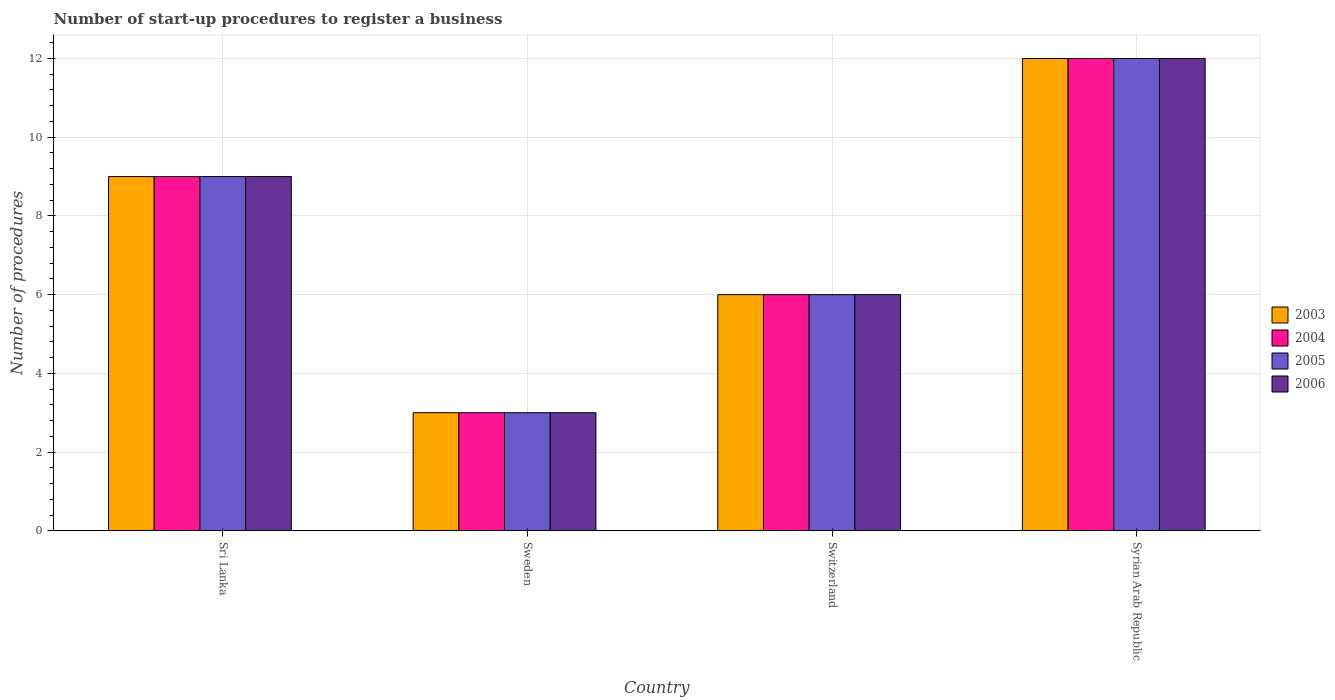How many groups of bars are there?
Provide a succinct answer. 4. Are the number of bars on each tick of the X-axis equal?
Ensure brevity in your answer.  Yes. How many bars are there on the 1st tick from the left?
Provide a succinct answer. 4. How many bars are there on the 1st tick from the right?
Give a very brief answer. 4. What is the label of the 3rd group of bars from the left?
Offer a very short reply. Switzerland. In which country was the number of procedures required to register a business in 2003 maximum?
Your answer should be compact. Syrian Arab Republic. What is the average number of procedures required to register a business in 2003 per country?
Your response must be concise. 7.5. What is the difference between the number of procedures required to register a business of/in 2005 and number of procedures required to register a business of/in 2003 in Syrian Arab Republic?
Offer a terse response. 0. In how many countries, is the number of procedures required to register a business in 2006 greater than 11.2?
Provide a short and direct response. 1. Is the number of procedures required to register a business in 2003 in Sri Lanka less than that in Sweden?
Provide a succinct answer. No. What is the difference between the highest and the lowest number of procedures required to register a business in 2006?
Your answer should be compact. 9. What does the 2nd bar from the left in Syrian Arab Republic represents?
Keep it short and to the point. 2004. What does the 4th bar from the right in Sri Lanka represents?
Your answer should be very brief. 2003. Is it the case that in every country, the sum of the number of procedures required to register a business in 2006 and number of procedures required to register a business in 2004 is greater than the number of procedures required to register a business in 2005?
Offer a terse response. Yes. Are all the bars in the graph horizontal?
Give a very brief answer. No. How many countries are there in the graph?
Provide a succinct answer. 4. What is the difference between two consecutive major ticks on the Y-axis?
Offer a very short reply. 2. Are the values on the major ticks of Y-axis written in scientific E-notation?
Ensure brevity in your answer.  No. Does the graph contain any zero values?
Your answer should be very brief. No. Where does the legend appear in the graph?
Your response must be concise. Center right. How many legend labels are there?
Ensure brevity in your answer.  4. What is the title of the graph?
Make the answer very short. Number of start-up procedures to register a business. What is the label or title of the X-axis?
Ensure brevity in your answer.  Country. What is the label or title of the Y-axis?
Ensure brevity in your answer.  Number of procedures. What is the Number of procedures of 2003 in Sri Lanka?
Provide a succinct answer. 9. What is the Number of procedures of 2003 in Sweden?
Your answer should be very brief. 3. What is the Number of procedures of 2004 in Sweden?
Offer a very short reply. 3. What is the Number of procedures in 2006 in Sweden?
Offer a very short reply. 3. What is the Number of procedures of 2005 in Switzerland?
Provide a short and direct response. 6. What is the Number of procedures in 2006 in Switzerland?
Offer a terse response. 6. What is the Number of procedures of 2006 in Syrian Arab Republic?
Provide a short and direct response. 12. Across all countries, what is the maximum Number of procedures of 2003?
Keep it short and to the point. 12. Across all countries, what is the maximum Number of procedures in 2005?
Keep it short and to the point. 12. Across all countries, what is the minimum Number of procedures in 2005?
Offer a very short reply. 3. Across all countries, what is the minimum Number of procedures of 2006?
Your answer should be very brief. 3. What is the total Number of procedures of 2006 in the graph?
Provide a succinct answer. 30. What is the difference between the Number of procedures of 2003 in Sri Lanka and that in Sweden?
Provide a short and direct response. 6. What is the difference between the Number of procedures in 2004 in Sri Lanka and that in Sweden?
Make the answer very short. 6. What is the difference between the Number of procedures of 2005 in Sri Lanka and that in Sweden?
Your response must be concise. 6. What is the difference between the Number of procedures of 2003 in Sri Lanka and that in Switzerland?
Provide a short and direct response. 3. What is the difference between the Number of procedures in 2005 in Sri Lanka and that in Switzerland?
Keep it short and to the point. 3. What is the difference between the Number of procedures in 2003 in Sri Lanka and that in Syrian Arab Republic?
Make the answer very short. -3. What is the difference between the Number of procedures in 2003 in Sweden and that in Switzerland?
Ensure brevity in your answer.  -3. What is the difference between the Number of procedures in 2005 in Sweden and that in Switzerland?
Give a very brief answer. -3. What is the difference between the Number of procedures of 2006 in Sweden and that in Switzerland?
Give a very brief answer. -3. What is the difference between the Number of procedures in 2003 in Sweden and that in Syrian Arab Republic?
Keep it short and to the point. -9. What is the difference between the Number of procedures in 2006 in Switzerland and that in Syrian Arab Republic?
Make the answer very short. -6. What is the difference between the Number of procedures in 2003 in Sri Lanka and the Number of procedures in 2004 in Sweden?
Provide a succinct answer. 6. What is the difference between the Number of procedures in 2004 in Sri Lanka and the Number of procedures in 2005 in Sweden?
Provide a succinct answer. 6. What is the difference between the Number of procedures in 2005 in Sri Lanka and the Number of procedures in 2006 in Sweden?
Offer a terse response. 6. What is the difference between the Number of procedures of 2003 in Sri Lanka and the Number of procedures of 2006 in Switzerland?
Offer a very short reply. 3. What is the difference between the Number of procedures in 2004 in Sri Lanka and the Number of procedures in 2006 in Switzerland?
Your answer should be very brief. 3. What is the difference between the Number of procedures in 2003 in Sri Lanka and the Number of procedures in 2004 in Syrian Arab Republic?
Your answer should be very brief. -3. What is the difference between the Number of procedures in 2003 in Sri Lanka and the Number of procedures in 2006 in Syrian Arab Republic?
Your answer should be compact. -3. What is the difference between the Number of procedures in 2005 in Sri Lanka and the Number of procedures in 2006 in Syrian Arab Republic?
Your answer should be very brief. -3. What is the difference between the Number of procedures of 2003 in Sweden and the Number of procedures of 2005 in Switzerland?
Give a very brief answer. -3. What is the difference between the Number of procedures of 2005 in Sweden and the Number of procedures of 2006 in Switzerland?
Your answer should be compact. -3. What is the difference between the Number of procedures of 2003 in Sweden and the Number of procedures of 2005 in Syrian Arab Republic?
Provide a succinct answer. -9. What is the difference between the Number of procedures of 2004 in Sweden and the Number of procedures of 2005 in Syrian Arab Republic?
Provide a short and direct response. -9. What is the difference between the Number of procedures of 2003 in Switzerland and the Number of procedures of 2004 in Syrian Arab Republic?
Keep it short and to the point. -6. What is the difference between the Number of procedures of 2003 in Switzerland and the Number of procedures of 2005 in Syrian Arab Republic?
Your response must be concise. -6. What is the difference between the Number of procedures in 2004 in Switzerland and the Number of procedures in 2005 in Syrian Arab Republic?
Your response must be concise. -6. What is the average Number of procedures of 2003 per country?
Ensure brevity in your answer.  7.5. What is the difference between the Number of procedures of 2003 and Number of procedures of 2004 in Sri Lanka?
Make the answer very short. 0. What is the difference between the Number of procedures of 2003 and Number of procedures of 2005 in Sri Lanka?
Give a very brief answer. 0. What is the difference between the Number of procedures of 2004 and Number of procedures of 2005 in Sri Lanka?
Keep it short and to the point. 0. What is the difference between the Number of procedures in 2004 and Number of procedures in 2006 in Sri Lanka?
Offer a terse response. 0. What is the difference between the Number of procedures of 2003 and Number of procedures of 2004 in Sweden?
Offer a very short reply. 0. What is the difference between the Number of procedures in 2003 and Number of procedures in 2005 in Sweden?
Provide a succinct answer. 0. What is the difference between the Number of procedures in 2003 and Number of procedures in 2006 in Sweden?
Your answer should be very brief. 0. What is the difference between the Number of procedures of 2004 and Number of procedures of 2006 in Sweden?
Make the answer very short. 0. What is the difference between the Number of procedures in 2005 and Number of procedures in 2006 in Sweden?
Offer a very short reply. 0. What is the difference between the Number of procedures of 2003 and Number of procedures of 2005 in Switzerland?
Provide a short and direct response. 0. What is the difference between the Number of procedures in 2003 and Number of procedures in 2006 in Switzerland?
Give a very brief answer. 0. What is the difference between the Number of procedures of 2004 and Number of procedures of 2005 in Switzerland?
Offer a very short reply. 0. What is the difference between the Number of procedures of 2003 and Number of procedures of 2004 in Syrian Arab Republic?
Your answer should be compact. 0. What is the difference between the Number of procedures of 2003 and Number of procedures of 2006 in Syrian Arab Republic?
Your response must be concise. 0. What is the difference between the Number of procedures of 2004 and Number of procedures of 2005 in Syrian Arab Republic?
Your response must be concise. 0. What is the difference between the Number of procedures of 2004 and Number of procedures of 2006 in Syrian Arab Republic?
Ensure brevity in your answer.  0. What is the difference between the Number of procedures of 2005 and Number of procedures of 2006 in Syrian Arab Republic?
Make the answer very short. 0. What is the ratio of the Number of procedures of 2005 in Sri Lanka to that in Sweden?
Offer a terse response. 3. What is the ratio of the Number of procedures in 2006 in Sri Lanka to that in Sweden?
Your answer should be very brief. 3. What is the ratio of the Number of procedures in 2004 in Sri Lanka to that in Switzerland?
Ensure brevity in your answer.  1.5. What is the ratio of the Number of procedures of 2005 in Sri Lanka to that in Switzerland?
Provide a succinct answer. 1.5. What is the ratio of the Number of procedures in 2006 in Sri Lanka to that in Switzerland?
Offer a very short reply. 1.5. What is the ratio of the Number of procedures of 2003 in Sri Lanka to that in Syrian Arab Republic?
Give a very brief answer. 0.75. What is the ratio of the Number of procedures in 2004 in Sri Lanka to that in Syrian Arab Republic?
Offer a terse response. 0.75. What is the ratio of the Number of procedures in 2003 in Sweden to that in Switzerland?
Make the answer very short. 0.5. What is the ratio of the Number of procedures of 2006 in Sweden to that in Switzerland?
Your response must be concise. 0.5. What is the ratio of the Number of procedures of 2003 in Sweden to that in Syrian Arab Republic?
Provide a succinct answer. 0.25. What is the ratio of the Number of procedures in 2005 in Sweden to that in Syrian Arab Republic?
Provide a short and direct response. 0.25. What is the ratio of the Number of procedures of 2006 in Sweden to that in Syrian Arab Republic?
Provide a short and direct response. 0.25. What is the ratio of the Number of procedures in 2005 in Switzerland to that in Syrian Arab Republic?
Your answer should be very brief. 0.5. What is the difference between the highest and the second highest Number of procedures of 2004?
Your answer should be very brief. 3. What is the difference between the highest and the lowest Number of procedures of 2003?
Offer a terse response. 9. What is the difference between the highest and the lowest Number of procedures in 2005?
Provide a succinct answer. 9. What is the difference between the highest and the lowest Number of procedures in 2006?
Offer a very short reply. 9. 